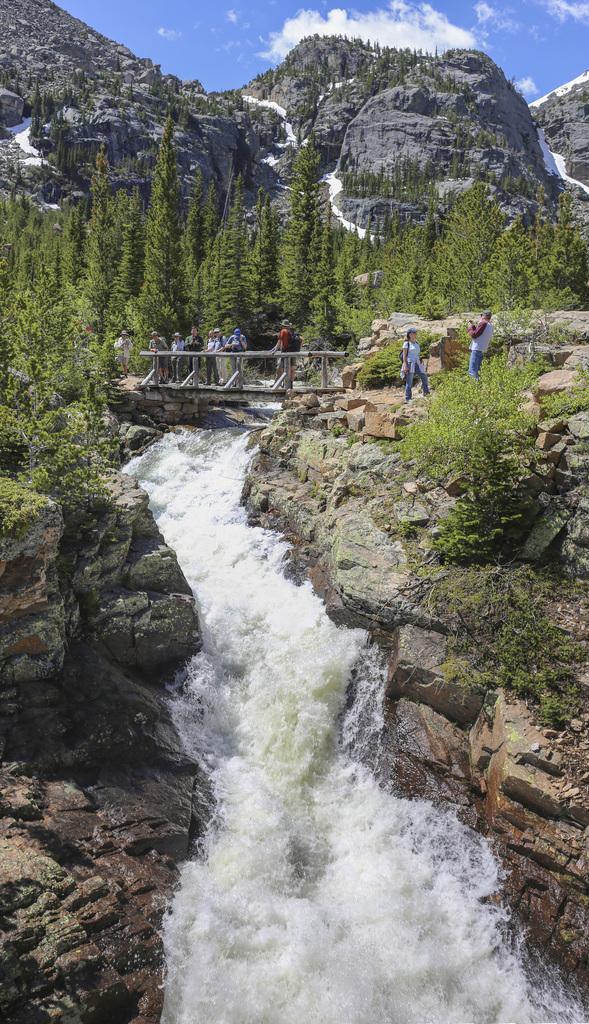Please provide a concise description of this image. This image is taken outdoors. At the top of the image there is the sky with clouds. In the background there are a few hills and there are few waterfalls. There are many trees and plants on the ground. In the middle of the image there is a bridge. A few people are standing on the bridge and a few are walking on the ground. On the left and right sides of the image there are many rocks. In the middle of the image there is a waterfall with water. 